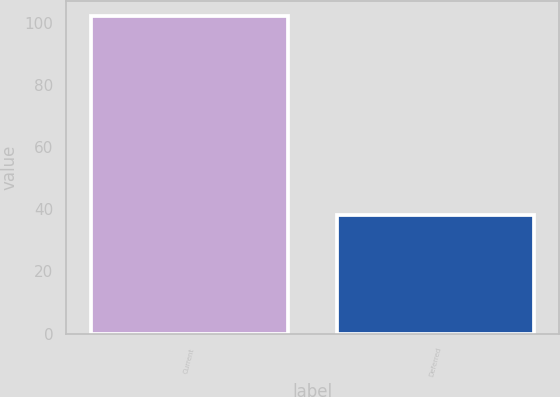Convert chart. <chart><loc_0><loc_0><loc_500><loc_500><bar_chart><fcel>Current<fcel>Deferred<nl><fcel>102<fcel>38<nl></chart> 